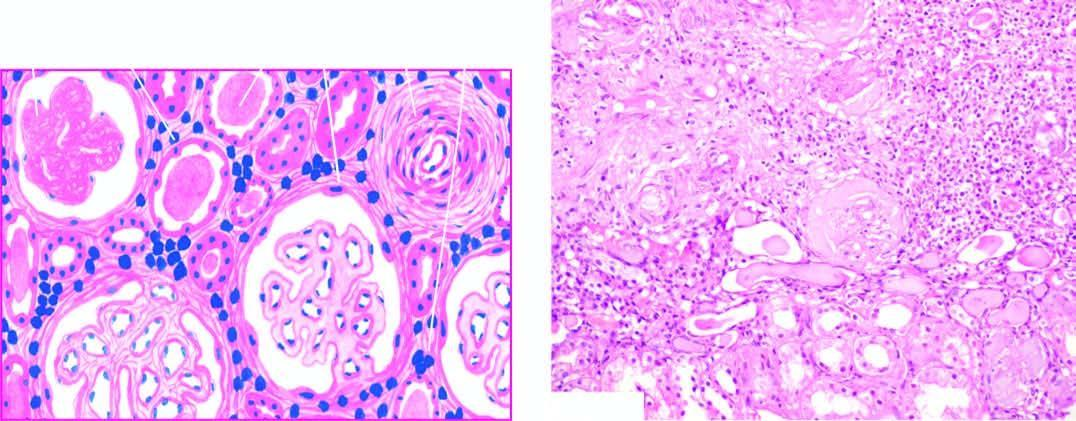what are the tubules surrounded by?
Answer the question using a single word or phrase. Abundant fibrous tissue and chronic interstitial inflammatory reaction 